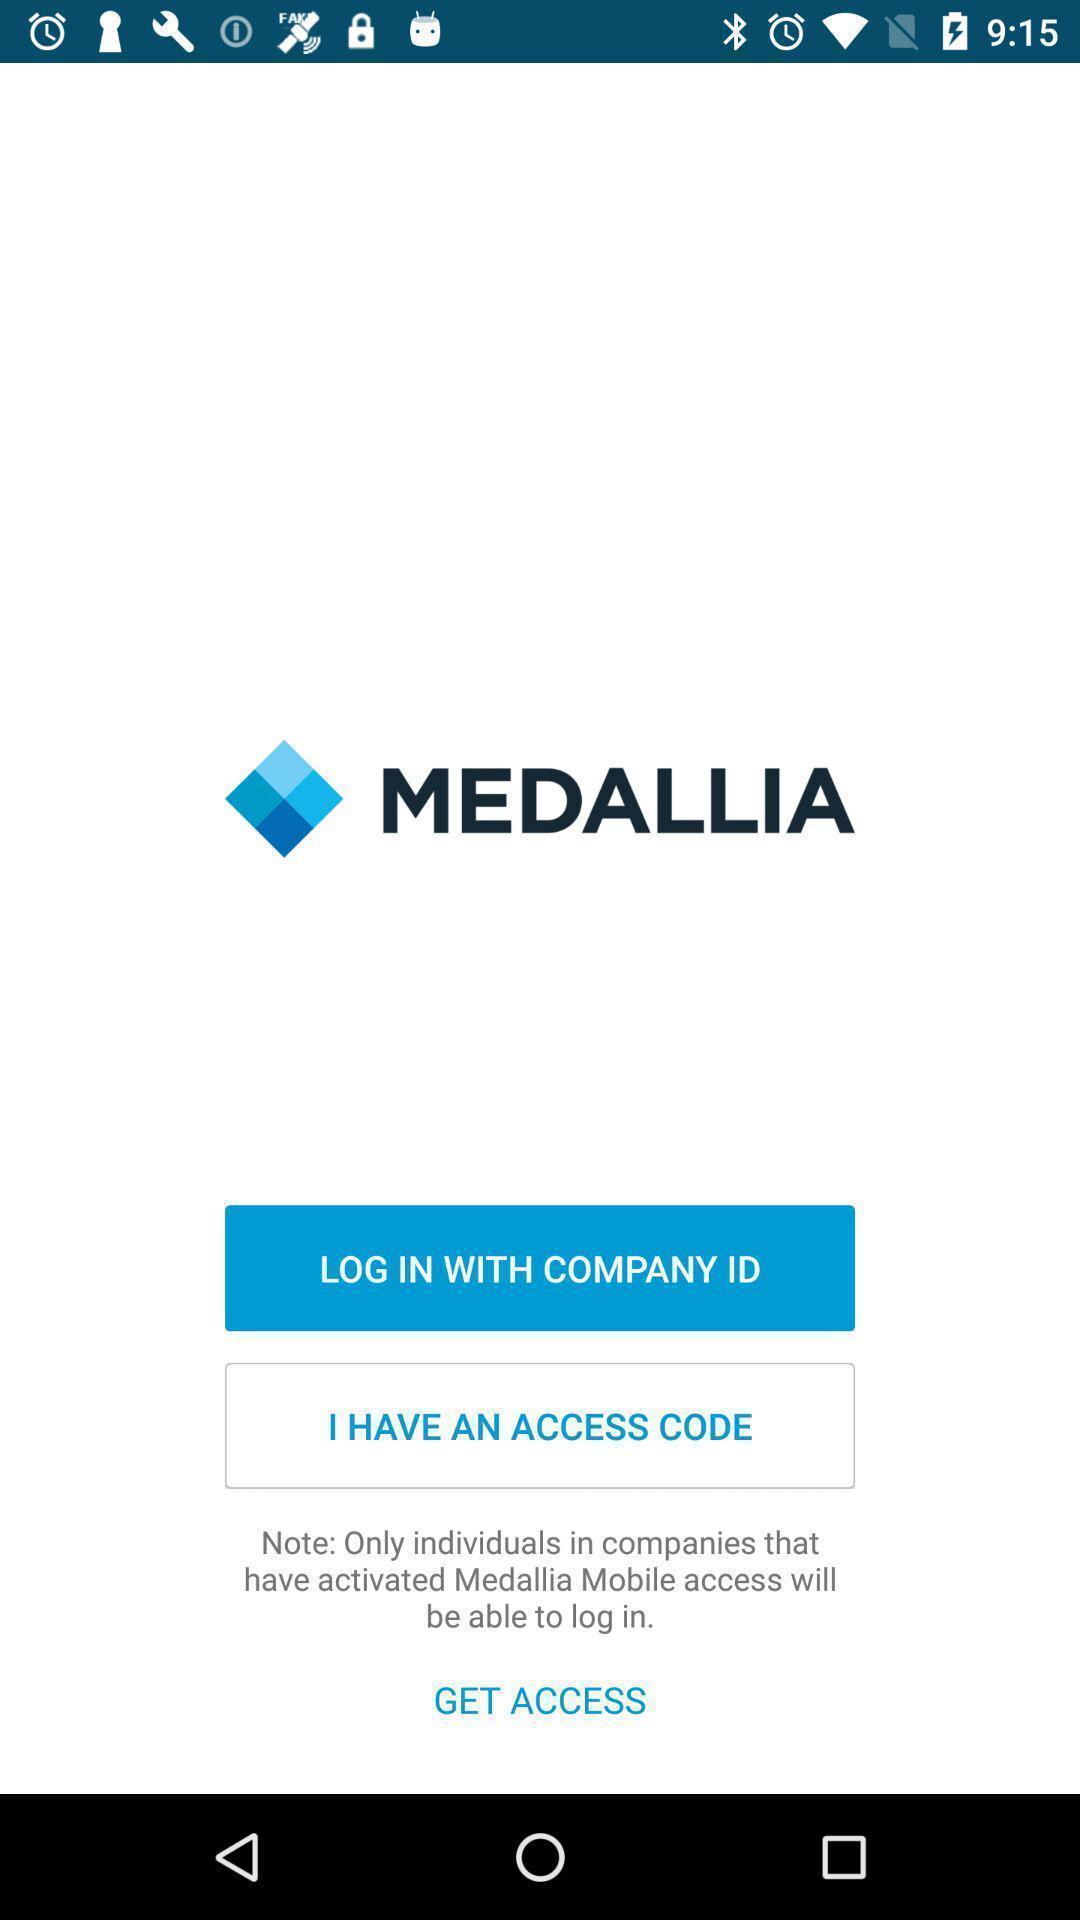Provide a description of this screenshot. Screen displaying home page of an management application. 